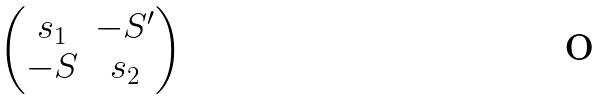Convert formula to latex. <formula><loc_0><loc_0><loc_500><loc_500>\begin{pmatrix} s _ { 1 } & - S ^ { \prime } \\ - S & s _ { 2 } \end{pmatrix}</formula> 